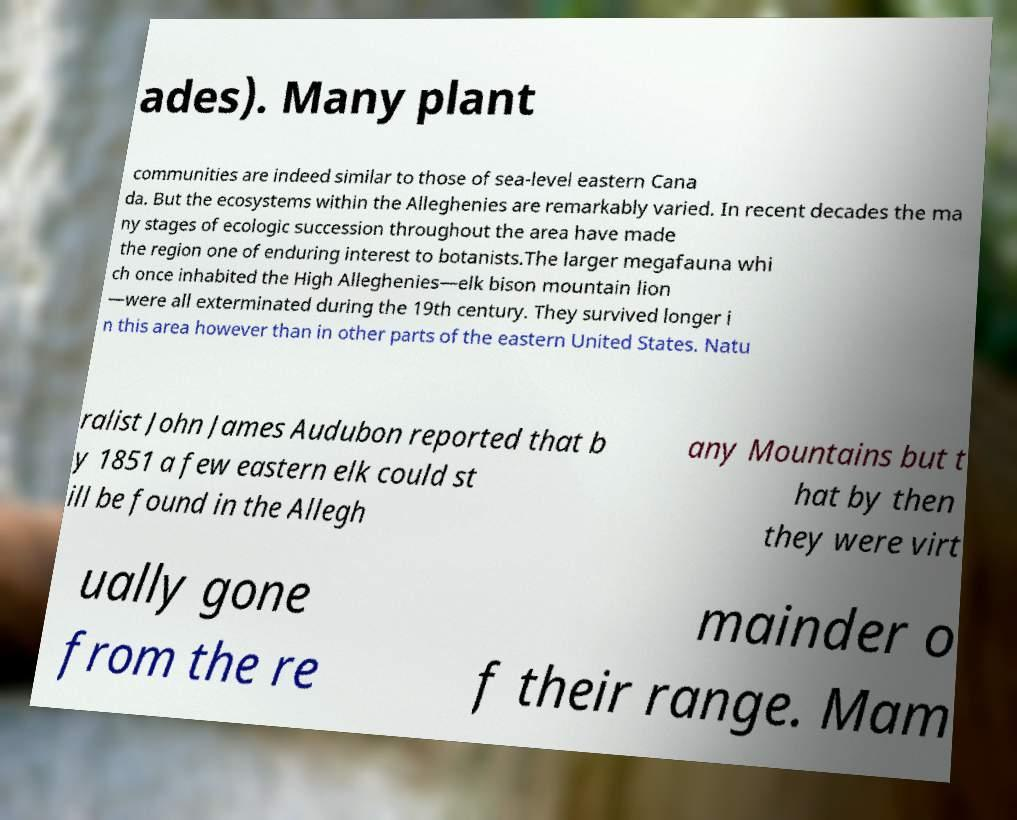Can you read and provide the text displayed in the image?This photo seems to have some interesting text. Can you extract and type it out for me? ades). Many plant communities are indeed similar to those of sea-level eastern Cana da. But the ecosystems within the Alleghenies are remarkably varied. In recent decades the ma ny stages of ecologic succession throughout the area have made the region one of enduring interest to botanists.The larger megafauna whi ch once inhabited the High Alleghenies—elk bison mountain lion —were all exterminated during the 19th century. They survived longer i n this area however than in other parts of the eastern United States. Natu ralist John James Audubon reported that b y 1851 a few eastern elk could st ill be found in the Allegh any Mountains but t hat by then they were virt ually gone from the re mainder o f their range. Mam 